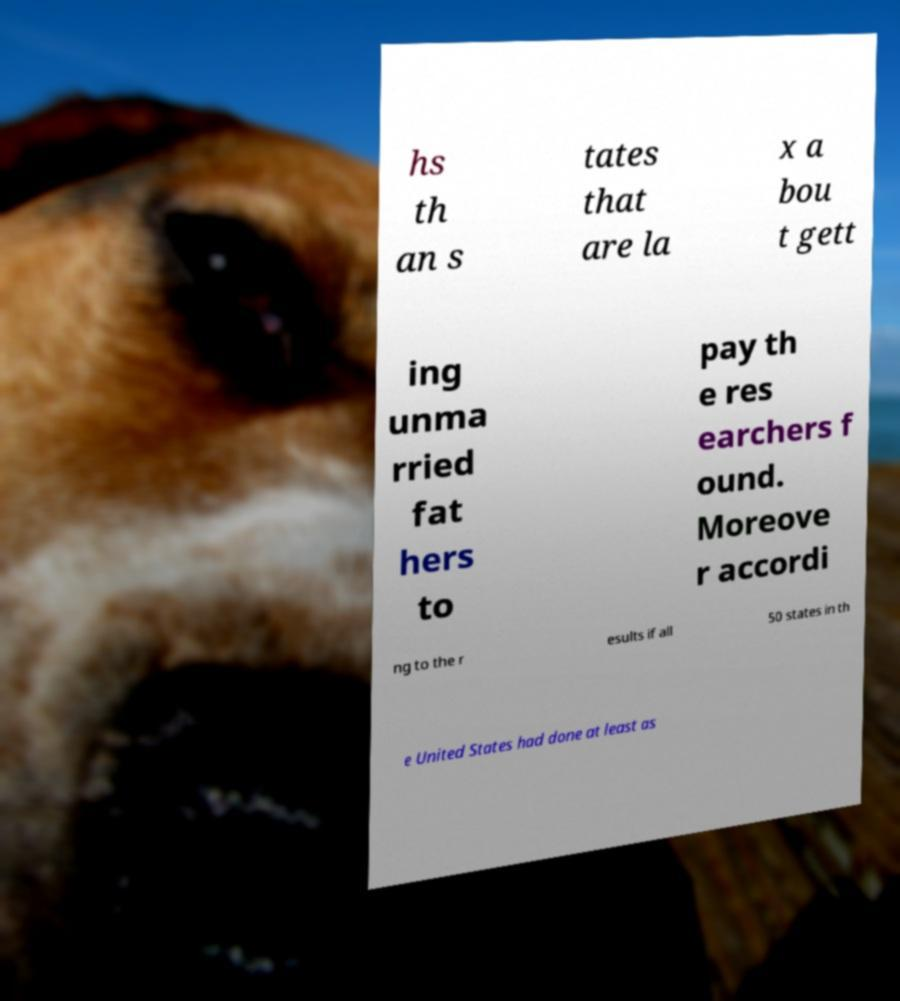Please identify and transcribe the text found in this image. hs th an s tates that are la x a bou t gett ing unma rried fat hers to pay th e res earchers f ound. Moreove r accordi ng to the r esults if all 50 states in th e United States had done at least as 